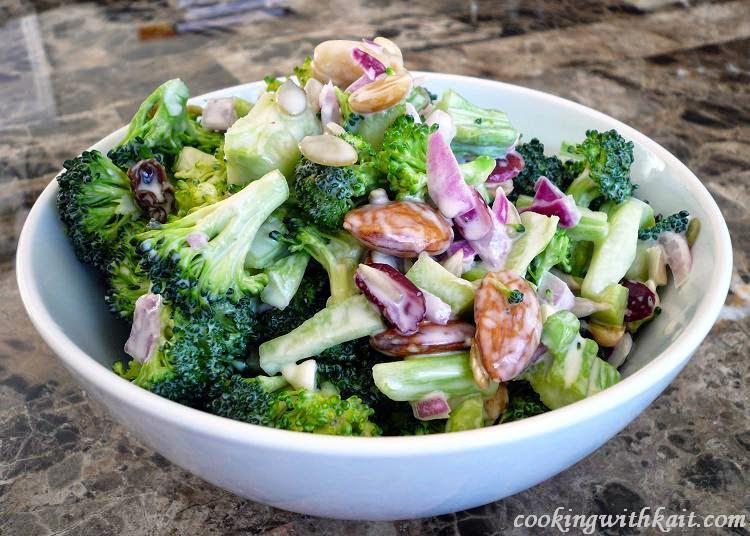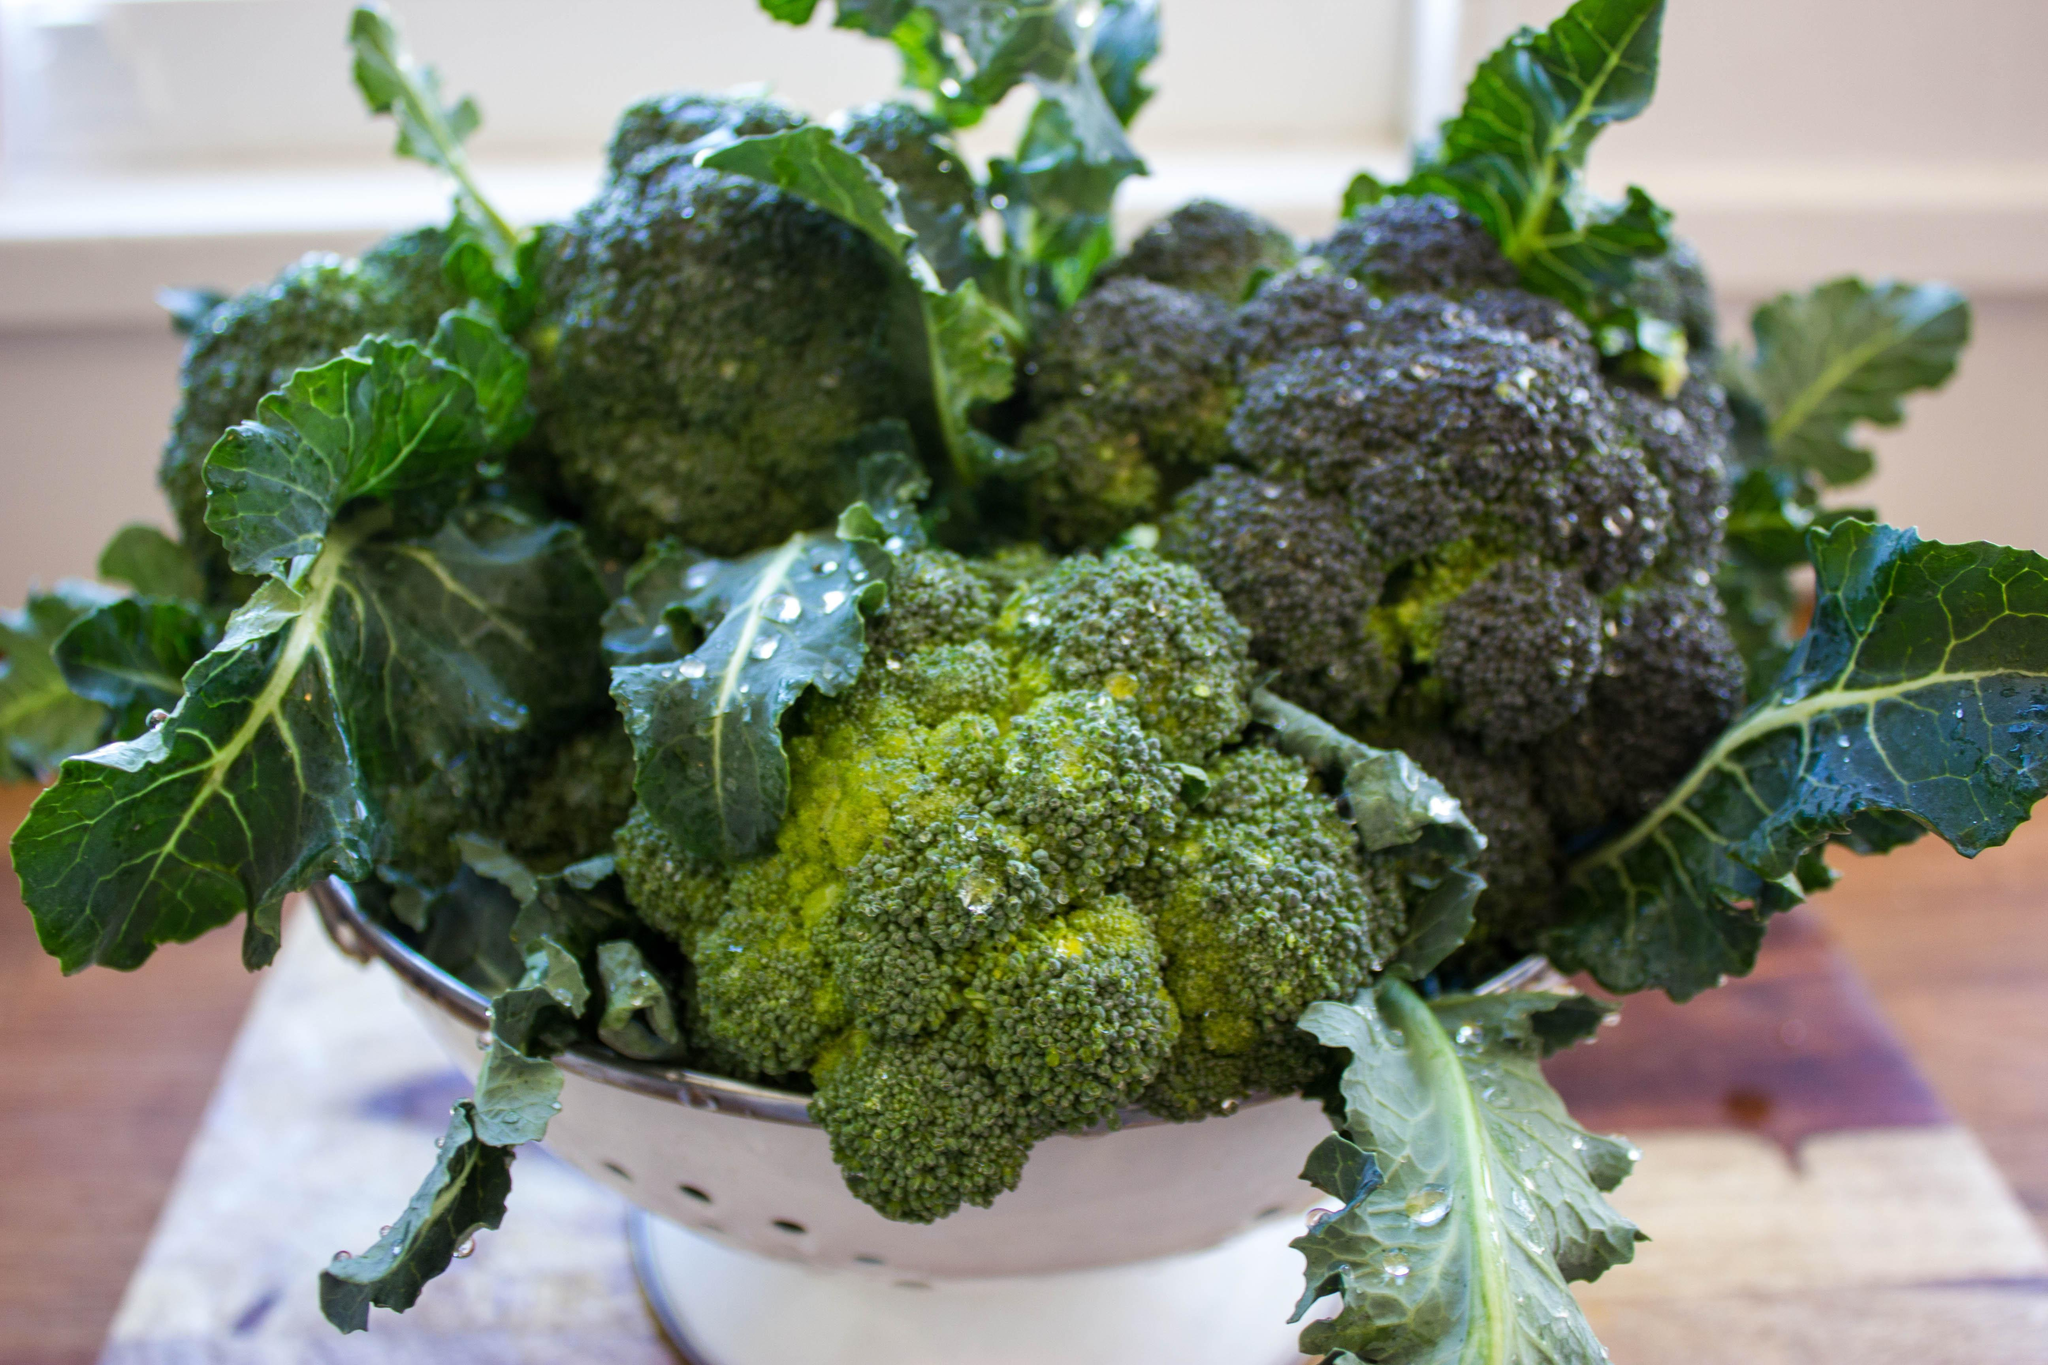The first image is the image on the left, the second image is the image on the right. Evaluate the accuracy of this statement regarding the images: "All images show broccoli in a round container of some type.". Is it true? Answer yes or no. Yes. The first image is the image on the left, the second image is the image on the right. Analyze the images presented: Is the assertion "There is a human head in the image on the right." valid? Answer yes or no. No. 